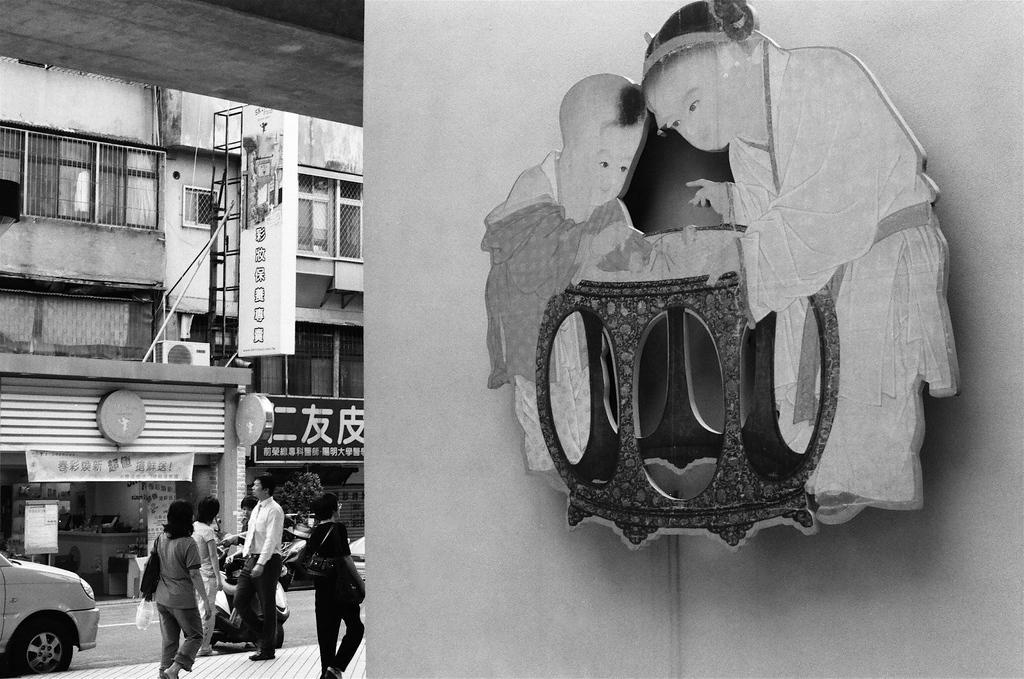Describe this image in one or two sentences. This is a black and white picture. On the right there is a hoarding to the wall. On the left, in the foreground there are people walking down the pavement. Beside them there is a road, on the road there are cars and vehicles. In the background there are buildings, hoardings and plants. At the top there are windows. 